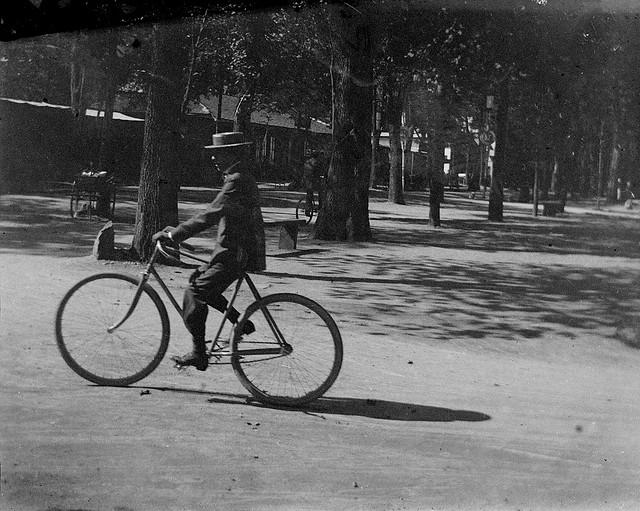What is this person sitting on?
Be succinct. Bike. Is the bike tied to the lamp post?
Answer briefly. No. Is a man on the bike?
Concise answer only. Yes. Where is the bench?
Quick response, please. Between trees. What is the man riding?
Answer briefly. Bicycle. Is there a taxi in the picture?
Short answer required. No. How fast is the bike moving?
Give a very brief answer. Slow. Is this a recent photo?
Give a very brief answer. No. 